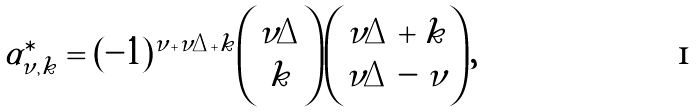Convert formula to latex. <formula><loc_0><loc_0><loc_500><loc_500>\alpha ^ { \ast } _ { \nu , k } = ( - 1 ) ^ { \nu + \nu \Delta + k } \binom { \nu \Delta } { k } \binom { \nu \Delta + k } { \nu \Delta - \nu } ,</formula> 